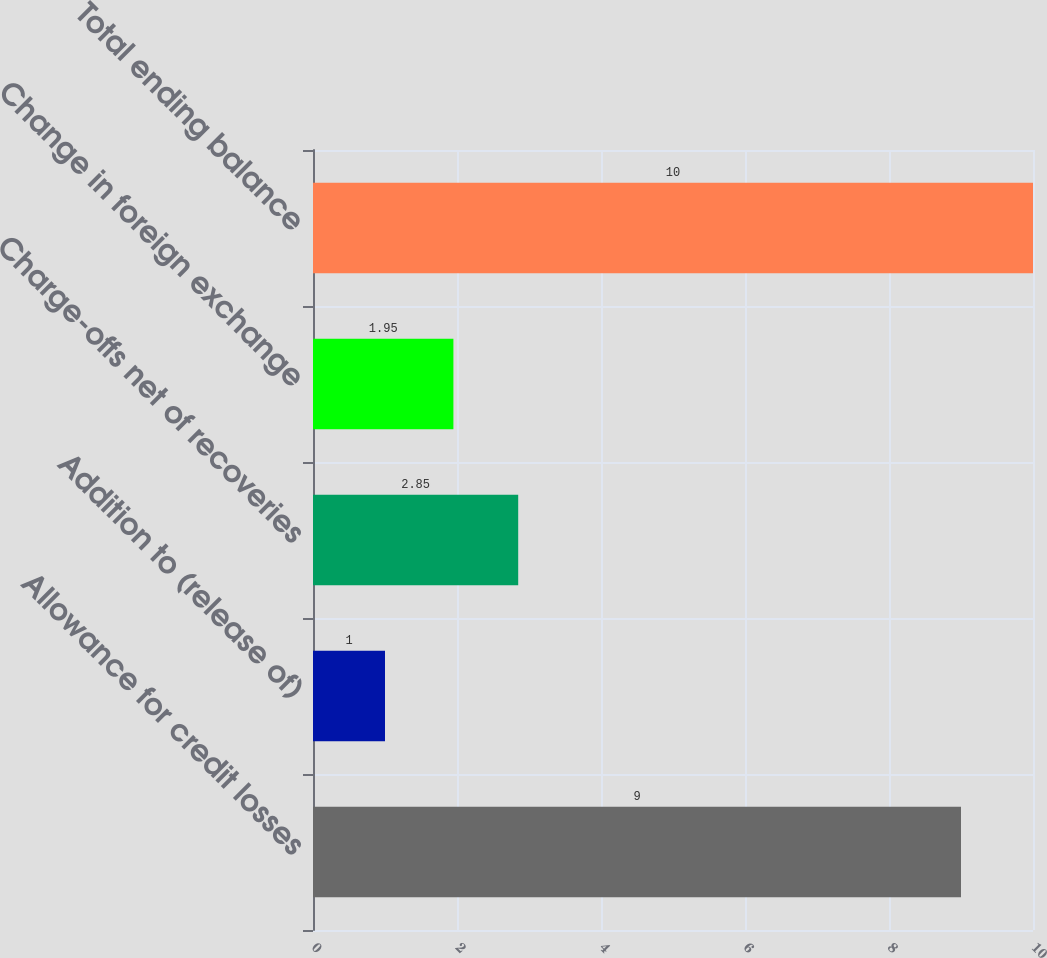Convert chart to OTSL. <chart><loc_0><loc_0><loc_500><loc_500><bar_chart><fcel>Allowance for credit losses<fcel>Addition to (release of)<fcel>Charge-offs net of recoveries<fcel>Change in foreign exchange<fcel>Total ending balance<nl><fcel>9<fcel>1<fcel>2.85<fcel>1.95<fcel>10<nl></chart> 